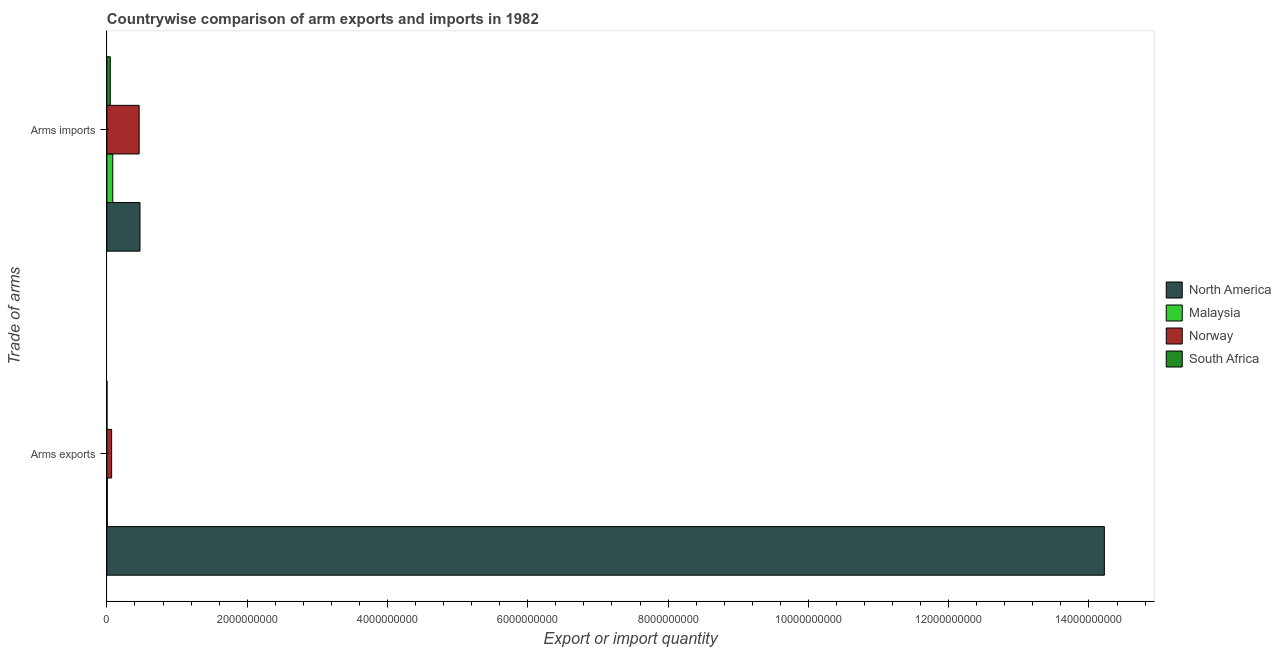How many different coloured bars are there?
Your response must be concise. 4. How many groups of bars are there?
Ensure brevity in your answer.  2. Are the number of bars per tick equal to the number of legend labels?
Offer a terse response. Yes. Are the number of bars on each tick of the Y-axis equal?
Offer a very short reply. Yes. How many bars are there on the 2nd tick from the bottom?
Ensure brevity in your answer.  4. What is the label of the 1st group of bars from the top?
Offer a very short reply. Arms imports. What is the arms imports in North America?
Keep it short and to the point. 4.72e+08. Across all countries, what is the maximum arms imports?
Your response must be concise. 4.72e+08. Across all countries, what is the minimum arms imports?
Make the answer very short. 4.90e+07. In which country was the arms exports maximum?
Give a very brief answer. North America. In which country was the arms imports minimum?
Your answer should be very brief. South Africa. What is the total arms imports in the graph?
Offer a terse response. 1.06e+09. What is the difference between the arms imports in Norway and that in South Africa?
Your answer should be compact. 4.11e+08. What is the difference between the arms imports in Norway and the arms exports in South Africa?
Offer a very short reply. 4.59e+08. What is the average arms exports per country?
Your answer should be very brief. 3.57e+09. What is the difference between the arms exports and arms imports in North America?
Make the answer very short. 1.37e+1. In how many countries, is the arms imports greater than 13600000000 ?
Make the answer very short. 0. Is the arms exports in Malaysia less than that in South Africa?
Your response must be concise. No. What does the 1st bar from the top in Arms exports represents?
Your answer should be very brief. South Africa. What does the 2nd bar from the bottom in Arms imports represents?
Ensure brevity in your answer.  Malaysia. How many bars are there?
Provide a short and direct response. 8. Are all the bars in the graph horizontal?
Your response must be concise. Yes. Does the graph contain grids?
Offer a very short reply. No. How are the legend labels stacked?
Offer a terse response. Vertical. What is the title of the graph?
Ensure brevity in your answer.  Countrywise comparison of arm exports and imports in 1982. Does "Sweden" appear as one of the legend labels in the graph?
Make the answer very short. No. What is the label or title of the X-axis?
Give a very brief answer. Export or import quantity. What is the label or title of the Y-axis?
Ensure brevity in your answer.  Trade of arms. What is the Export or import quantity of North America in Arms exports?
Give a very brief answer. 1.42e+1. What is the Export or import quantity in Norway in Arms exports?
Your response must be concise. 6.80e+07. What is the Export or import quantity in North America in Arms imports?
Ensure brevity in your answer.  4.72e+08. What is the Export or import quantity of Malaysia in Arms imports?
Provide a short and direct response. 8.40e+07. What is the Export or import quantity in Norway in Arms imports?
Your response must be concise. 4.60e+08. What is the Export or import quantity of South Africa in Arms imports?
Provide a short and direct response. 4.90e+07. Across all Trade of arms, what is the maximum Export or import quantity in North America?
Your response must be concise. 1.42e+1. Across all Trade of arms, what is the maximum Export or import quantity in Malaysia?
Provide a succinct answer. 8.40e+07. Across all Trade of arms, what is the maximum Export or import quantity of Norway?
Offer a terse response. 4.60e+08. Across all Trade of arms, what is the maximum Export or import quantity of South Africa?
Offer a very short reply. 4.90e+07. Across all Trade of arms, what is the minimum Export or import quantity in North America?
Keep it short and to the point. 4.72e+08. Across all Trade of arms, what is the minimum Export or import quantity in Norway?
Your response must be concise. 6.80e+07. What is the total Export or import quantity of North America in the graph?
Your answer should be compact. 1.47e+1. What is the total Export or import quantity in Malaysia in the graph?
Keep it short and to the point. 9.00e+07. What is the total Export or import quantity of Norway in the graph?
Provide a succinct answer. 5.28e+08. What is the total Export or import quantity in South Africa in the graph?
Provide a succinct answer. 5.00e+07. What is the difference between the Export or import quantity in North America in Arms exports and that in Arms imports?
Your response must be concise. 1.37e+1. What is the difference between the Export or import quantity of Malaysia in Arms exports and that in Arms imports?
Offer a very short reply. -7.80e+07. What is the difference between the Export or import quantity in Norway in Arms exports and that in Arms imports?
Offer a terse response. -3.92e+08. What is the difference between the Export or import quantity of South Africa in Arms exports and that in Arms imports?
Offer a terse response. -4.80e+07. What is the difference between the Export or import quantity of North America in Arms exports and the Export or import quantity of Malaysia in Arms imports?
Your answer should be very brief. 1.41e+1. What is the difference between the Export or import quantity of North America in Arms exports and the Export or import quantity of Norway in Arms imports?
Make the answer very short. 1.38e+1. What is the difference between the Export or import quantity of North America in Arms exports and the Export or import quantity of South Africa in Arms imports?
Provide a succinct answer. 1.42e+1. What is the difference between the Export or import quantity of Malaysia in Arms exports and the Export or import quantity of Norway in Arms imports?
Make the answer very short. -4.54e+08. What is the difference between the Export or import quantity of Malaysia in Arms exports and the Export or import quantity of South Africa in Arms imports?
Keep it short and to the point. -4.30e+07. What is the difference between the Export or import quantity of Norway in Arms exports and the Export or import quantity of South Africa in Arms imports?
Provide a succinct answer. 1.90e+07. What is the average Export or import quantity in North America per Trade of arms?
Offer a terse response. 7.35e+09. What is the average Export or import quantity of Malaysia per Trade of arms?
Your answer should be compact. 4.50e+07. What is the average Export or import quantity in Norway per Trade of arms?
Give a very brief answer. 2.64e+08. What is the average Export or import quantity of South Africa per Trade of arms?
Your answer should be very brief. 2.50e+07. What is the difference between the Export or import quantity in North America and Export or import quantity in Malaysia in Arms exports?
Your answer should be very brief. 1.42e+1. What is the difference between the Export or import quantity of North America and Export or import quantity of Norway in Arms exports?
Provide a succinct answer. 1.42e+1. What is the difference between the Export or import quantity in North America and Export or import quantity in South Africa in Arms exports?
Offer a terse response. 1.42e+1. What is the difference between the Export or import quantity in Malaysia and Export or import quantity in Norway in Arms exports?
Provide a short and direct response. -6.20e+07. What is the difference between the Export or import quantity of Malaysia and Export or import quantity of South Africa in Arms exports?
Your answer should be very brief. 5.00e+06. What is the difference between the Export or import quantity in Norway and Export or import quantity in South Africa in Arms exports?
Provide a short and direct response. 6.70e+07. What is the difference between the Export or import quantity in North America and Export or import quantity in Malaysia in Arms imports?
Your answer should be compact. 3.88e+08. What is the difference between the Export or import quantity in North America and Export or import quantity in Norway in Arms imports?
Offer a terse response. 1.20e+07. What is the difference between the Export or import quantity in North America and Export or import quantity in South Africa in Arms imports?
Offer a terse response. 4.23e+08. What is the difference between the Export or import quantity in Malaysia and Export or import quantity in Norway in Arms imports?
Offer a terse response. -3.76e+08. What is the difference between the Export or import quantity in Malaysia and Export or import quantity in South Africa in Arms imports?
Give a very brief answer. 3.50e+07. What is the difference between the Export or import quantity of Norway and Export or import quantity of South Africa in Arms imports?
Your answer should be very brief. 4.11e+08. What is the ratio of the Export or import quantity in North America in Arms exports to that in Arms imports?
Ensure brevity in your answer.  30.12. What is the ratio of the Export or import quantity of Malaysia in Arms exports to that in Arms imports?
Keep it short and to the point. 0.07. What is the ratio of the Export or import quantity in Norway in Arms exports to that in Arms imports?
Ensure brevity in your answer.  0.15. What is the ratio of the Export or import quantity of South Africa in Arms exports to that in Arms imports?
Provide a succinct answer. 0.02. What is the difference between the highest and the second highest Export or import quantity in North America?
Provide a short and direct response. 1.37e+1. What is the difference between the highest and the second highest Export or import quantity of Malaysia?
Provide a short and direct response. 7.80e+07. What is the difference between the highest and the second highest Export or import quantity in Norway?
Your answer should be compact. 3.92e+08. What is the difference between the highest and the second highest Export or import quantity in South Africa?
Your answer should be very brief. 4.80e+07. What is the difference between the highest and the lowest Export or import quantity in North America?
Make the answer very short. 1.37e+1. What is the difference between the highest and the lowest Export or import quantity in Malaysia?
Offer a very short reply. 7.80e+07. What is the difference between the highest and the lowest Export or import quantity of Norway?
Provide a short and direct response. 3.92e+08. What is the difference between the highest and the lowest Export or import quantity of South Africa?
Offer a very short reply. 4.80e+07. 